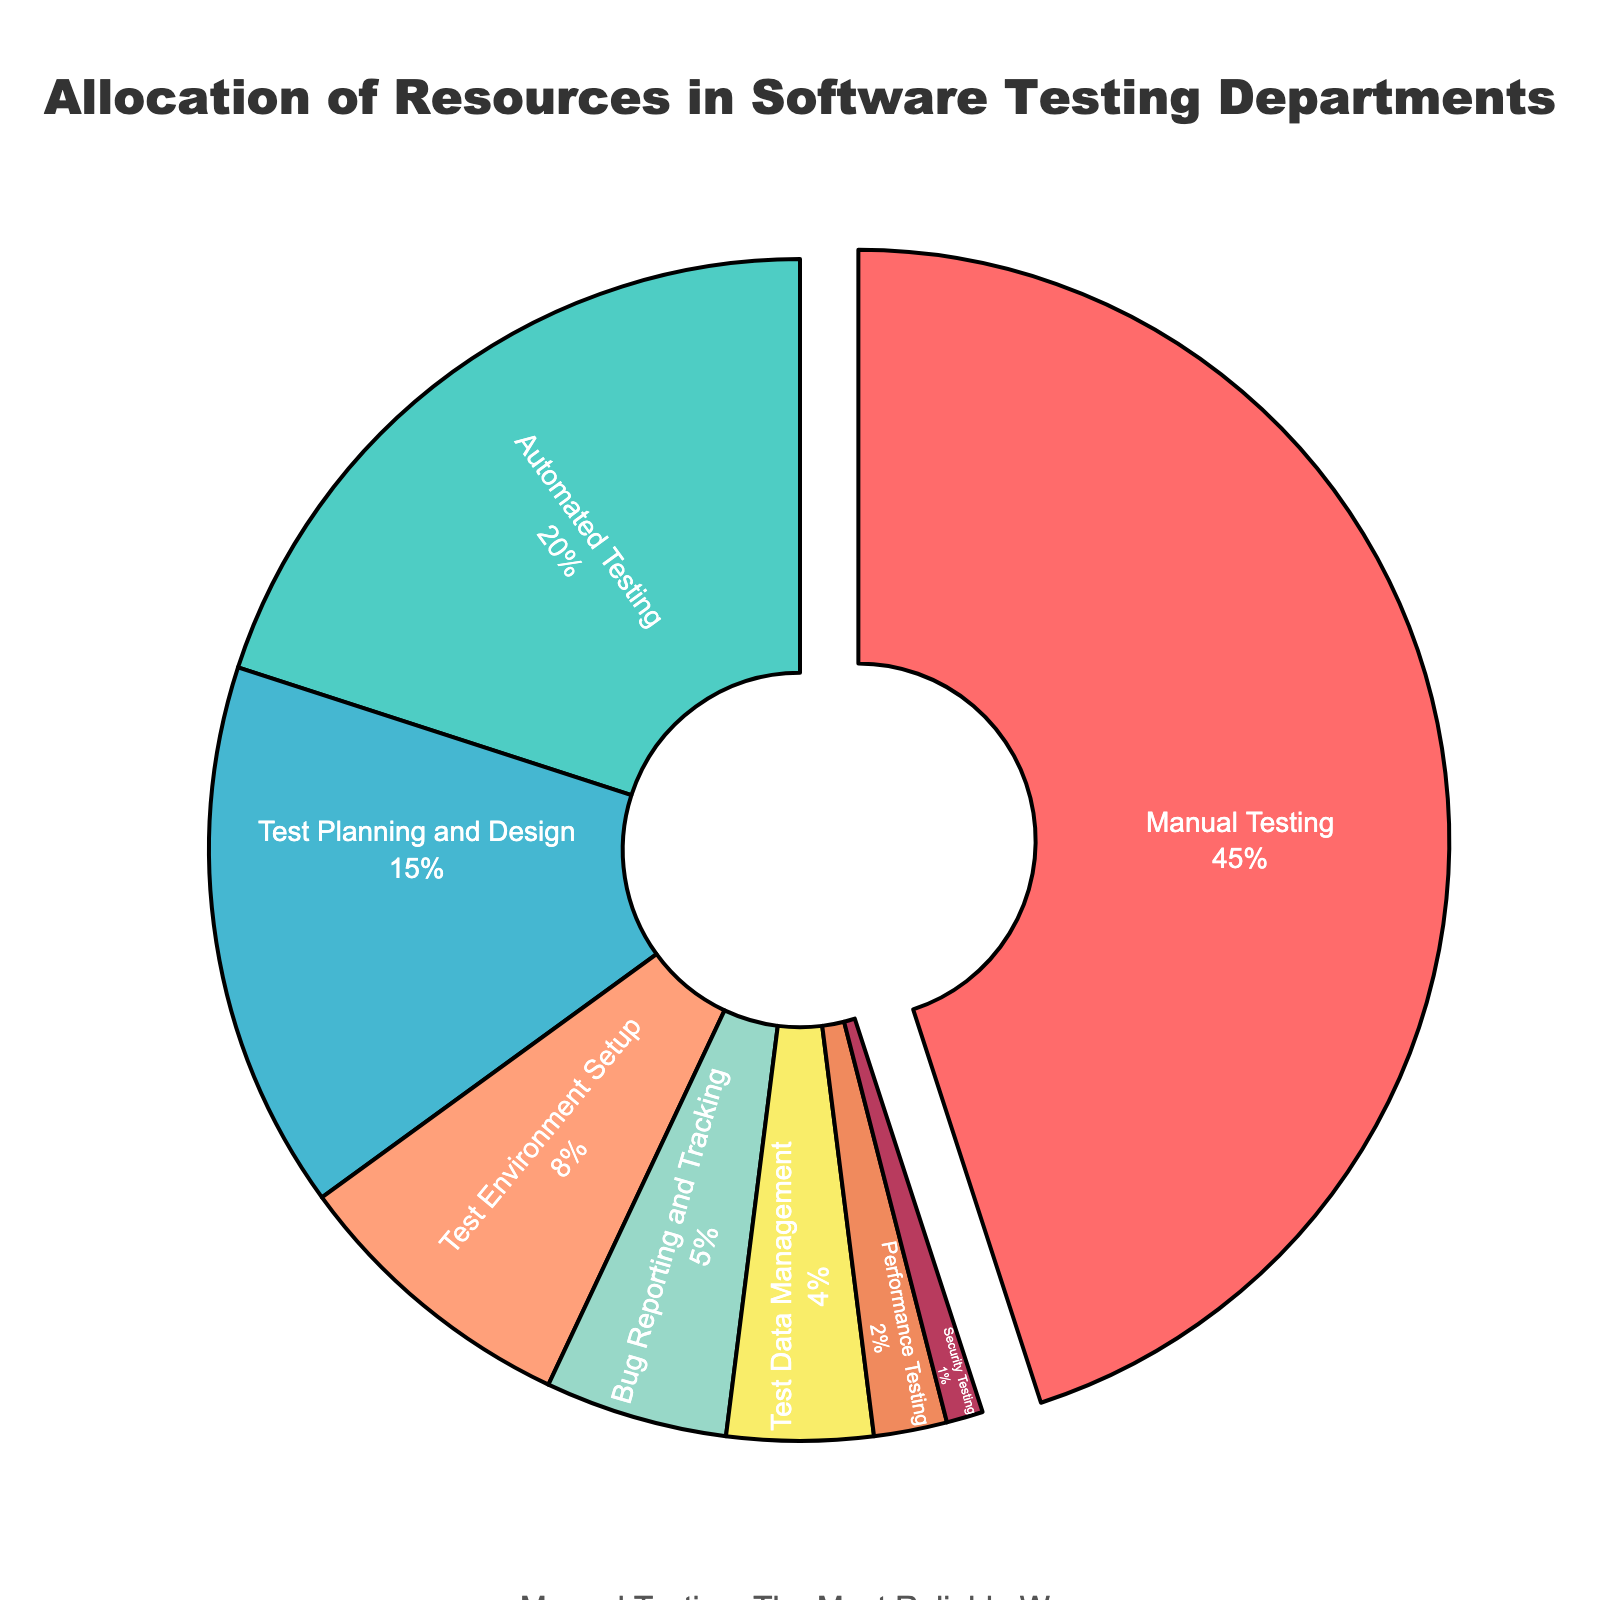What percentage of resources is allocated to manual testing? Check the pie chart section labeled 'Manual Testing' and refer to the text inside. Manual Testing is shown with 45%.
Answer: 45% Which resource type has the second-largest allocation? Identify the section with the second-largest percentage value after Manual Testing. 'Automated Testing' is next with 20%.
Answer: Automated Testing What is the total percentage of resources allocated to test planning & design, and test environment setup combined? Add the percentages for 'Test Planning and Design' and 'Test Environment Setup'. 15% (Test Planning and Design) + 8% (Test Environment Setup) = 23%.
Answer: 23% By how much does the manual testing resource allocation exceed the automated testing allocation? Subtract the percentage of 'Automated Testing' from 'Manual Testing'. 45% (Manual Testing) - 20% (Automated Testing) = 25%.
Answer: 25% Identify the resource with the lowest allocation and state its percentage. Find the pie chart section with the smallest percentage value. 'Security Testing' is the smallest with 1%.
Answer: Security Testing, 1% Compare the resource allocations for bug reporting and tracking versus performance testing. Which one has a higher allocation, and by how much? Subtract the percentage of 'Performance Testing' from 'Bug Reporting and Tracking'. 'Bug Reporting and Tracking' has 5% and 'Performance Testing' has 2%, so 5% - 2% = 3%.
Answer: Bug Reporting and Tracking, 3% What percentage of resources is dedicated to areas other than manual testing? Subtract the percentage for 'Manual Testing' from the total (100%). 100% - 45% = 55%.
Answer: 55% If manual testing is highlighted by being pulled out from the pie, why might this be the case? Given the context that the viewer believes in the reliability of manual testing, it is likely emphasized due to its prominence in resource allocation and perceived importance in identifying bugs.
Answer: Emphasized for importance 